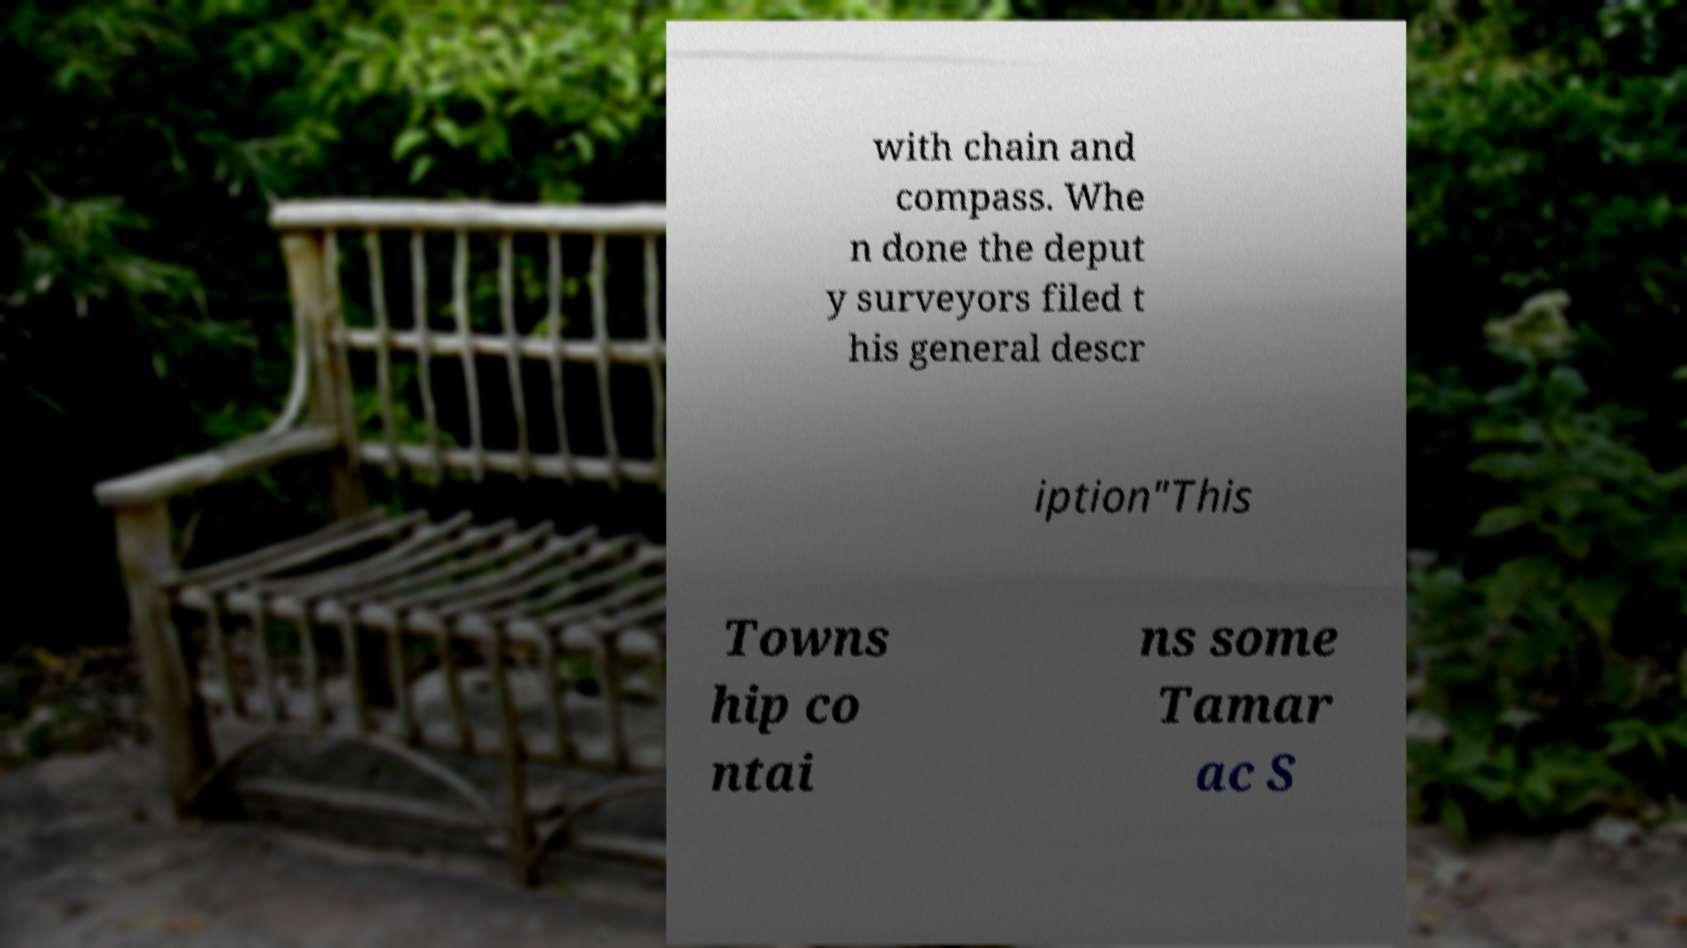Could you extract and type out the text from this image? with chain and compass. Whe n done the deput y surveyors filed t his general descr iption"This Towns hip co ntai ns some Tamar ac S 